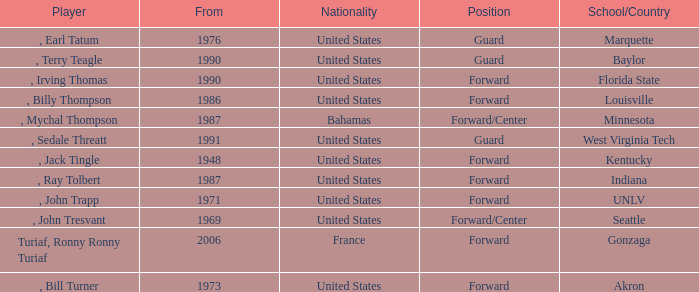What was the nationality of all players from the year 1976? United States. 